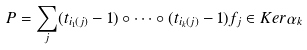<formula> <loc_0><loc_0><loc_500><loc_500>P = \sum _ { j } ( t _ { i _ { 1 } ( j ) } - 1 ) \circ \dots \circ ( t _ { i _ { k } ( j ) } - 1 ) f _ { j } \in K e r \alpha _ { k }</formula> 